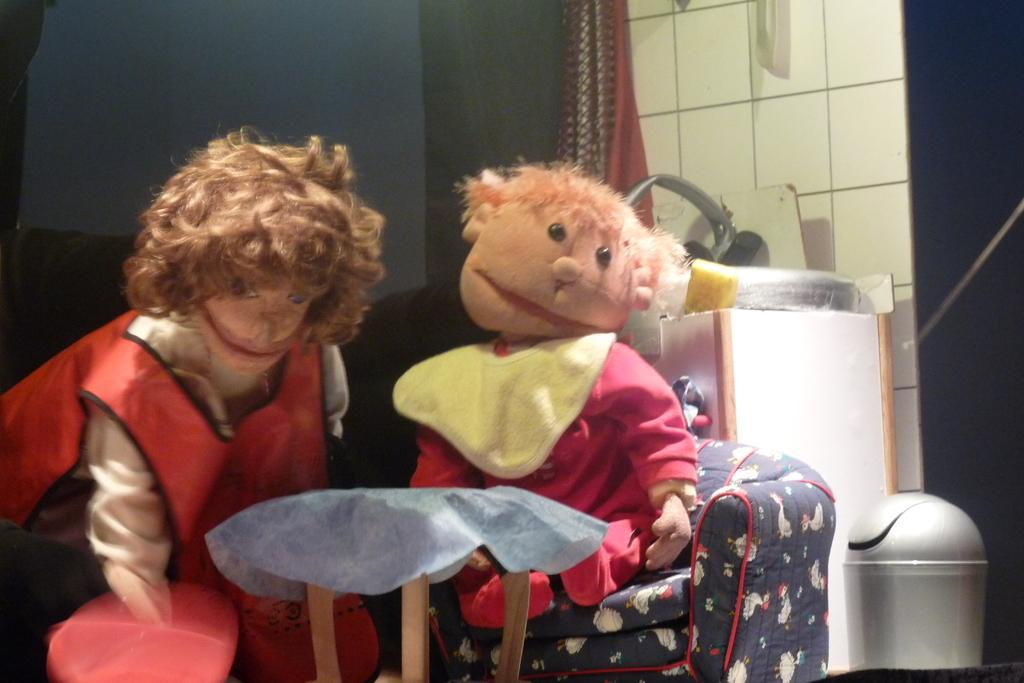How many toys can be seen in the image? There are two toys in the image. What type of furniture is present in the image? There is a couch in the image. What is used for disposing of waste in the image? There is a garbage bin in the image. What type of architectural feature is present in the image? There is a wall in the image. What type of window treatment is present in the image? There are curtains in the image. Can you describe any other objects in the image? There are some unspecified objects in the image. What type of apparatus is used for giving advice in the image? There is no apparatus for giving advice present in the image. Can you describe the conversation happening between the toys in the image? There is no conversation between the toys in the image, as toys do not talk. 